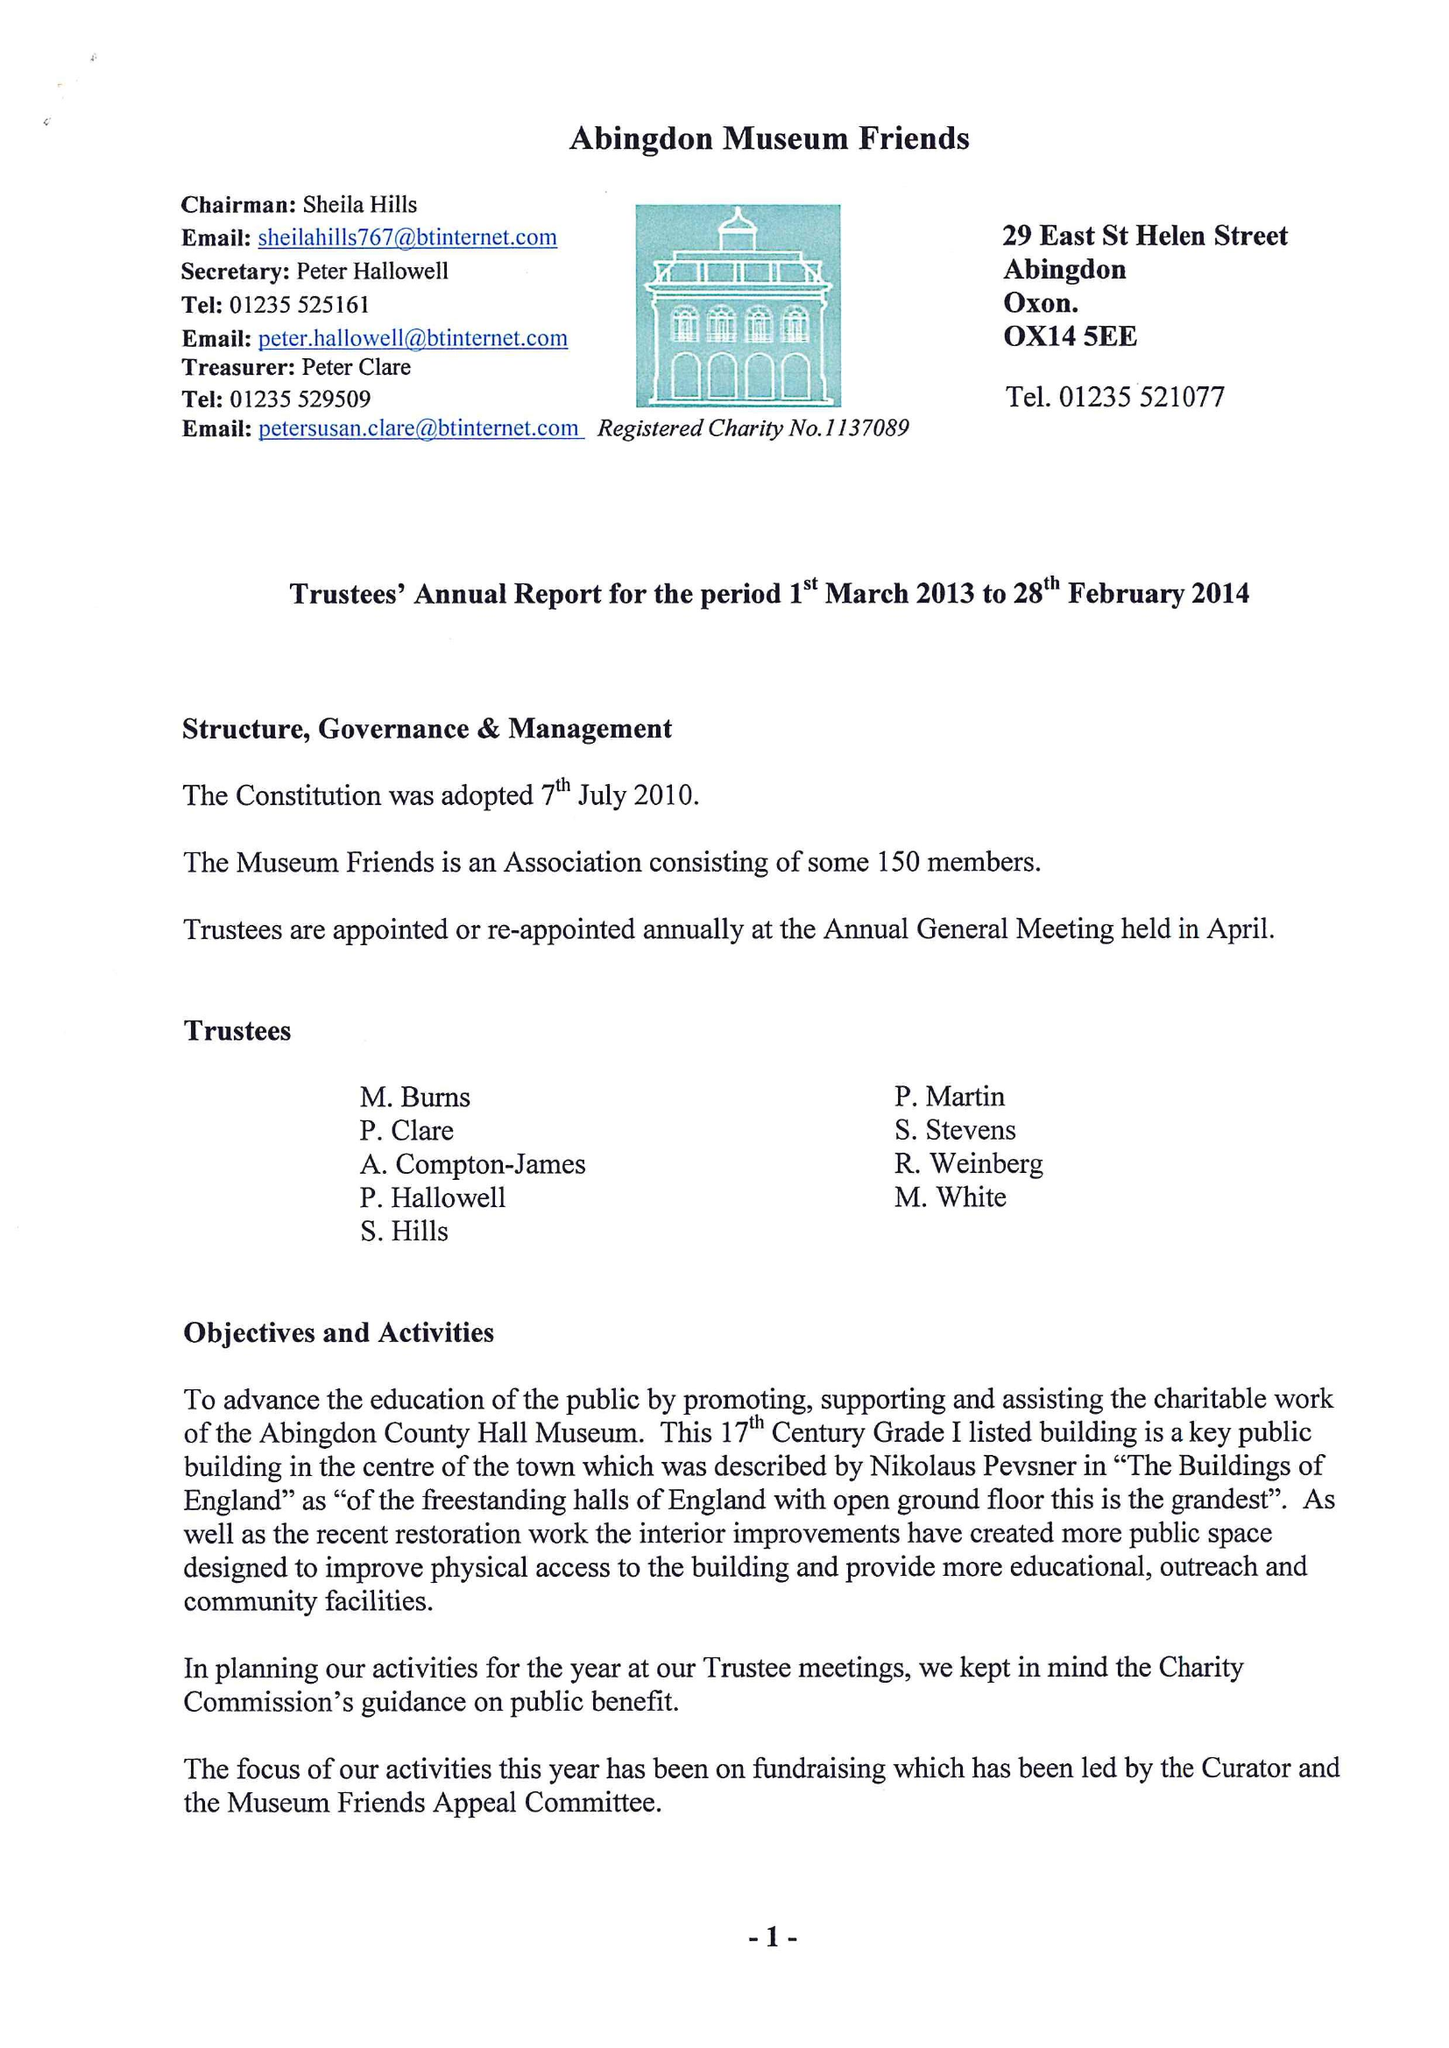What is the value for the income_annually_in_british_pounds?
Answer the question using a single word or phrase. 31374.00 